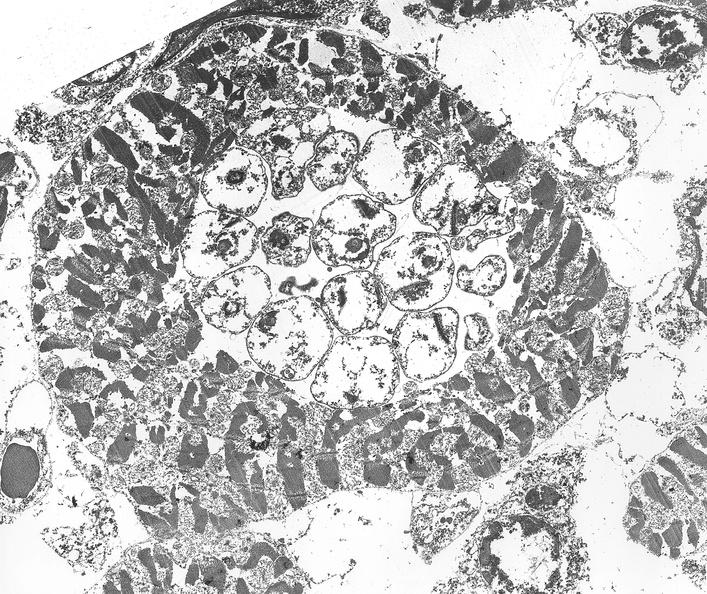what is present?
Answer the question using a single word or phrase. Cardiovascular 